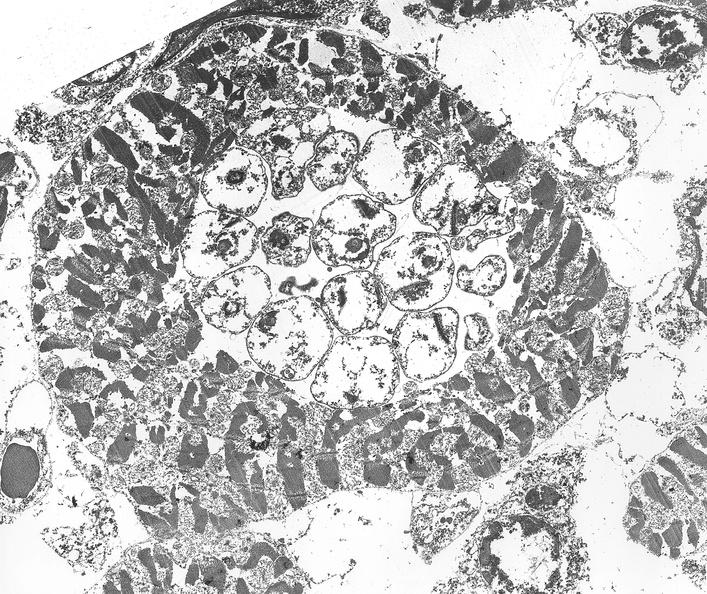what is present?
Answer the question using a single word or phrase. Cardiovascular 